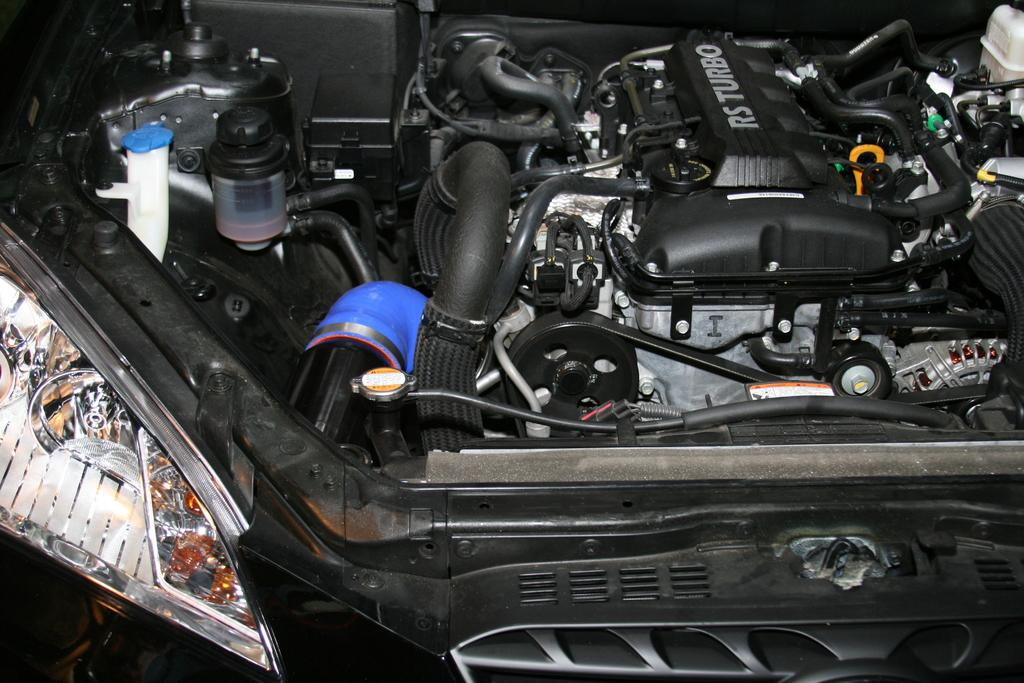What is the main subject of the image? The main subject of the image is an engine. To which type of vehicle does the engine belong? The engine belongs to a vehicle. What additional detail can be observed on the engine? There is text written on the engine. How many dolls are sitting on the stone in the image? There are no dolls or stones present in the image; it features an engine with text written on it. 